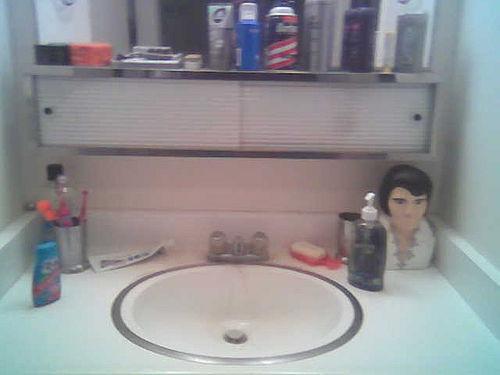How many bottles are there?
Give a very brief answer. 2. 